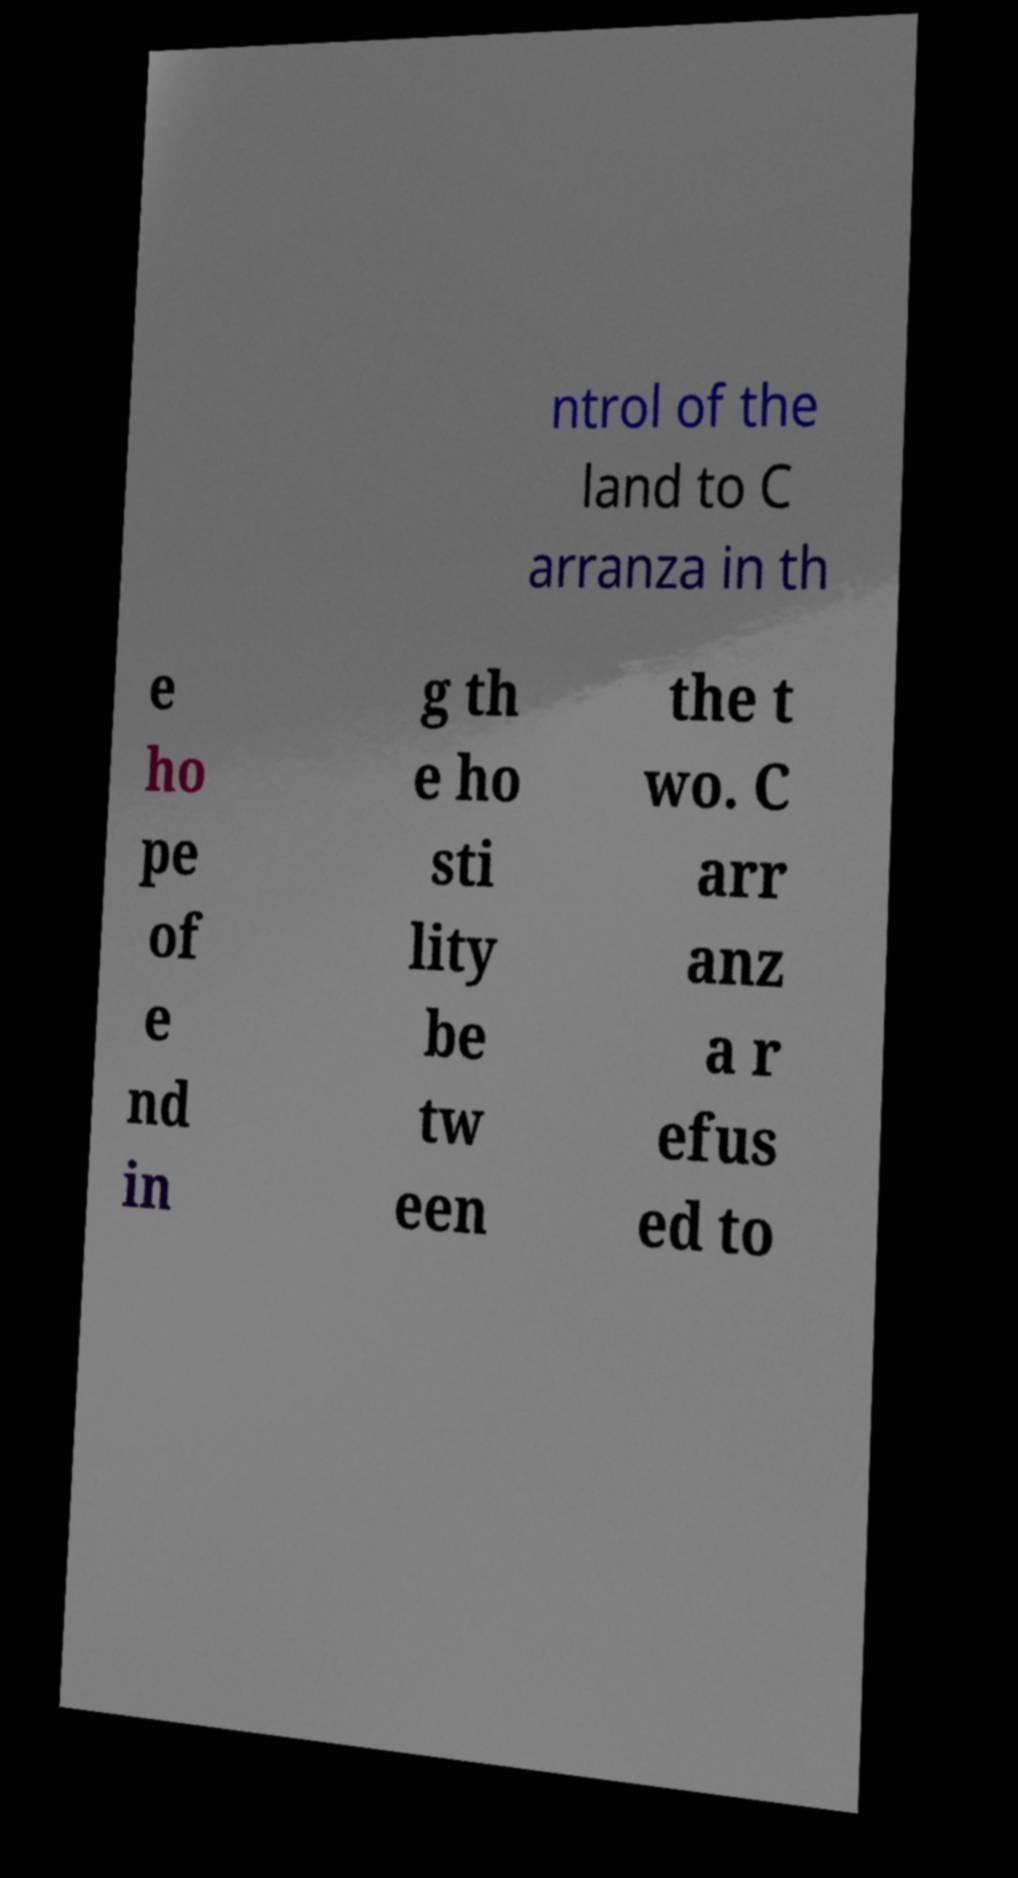Could you assist in decoding the text presented in this image and type it out clearly? ntrol of the land to C arranza in th e ho pe of e nd in g th e ho sti lity be tw een the t wo. C arr anz a r efus ed to 